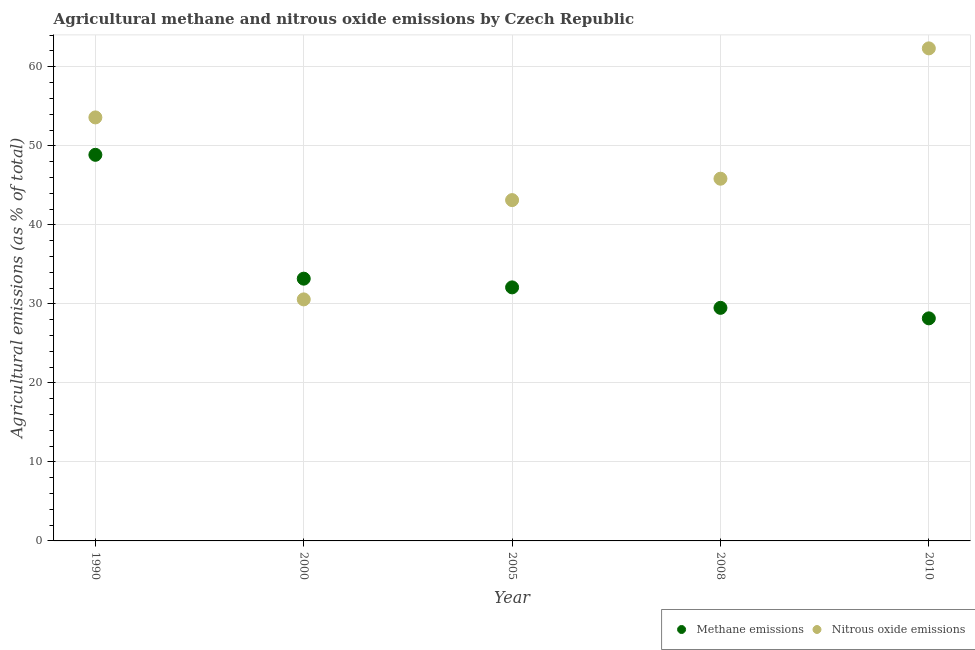What is the amount of methane emissions in 2000?
Your response must be concise. 33.19. Across all years, what is the maximum amount of nitrous oxide emissions?
Your answer should be very brief. 62.33. Across all years, what is the minimum amount of methane emissions?
Offer a very short reply. 28.17. In which year was the amount of nitrous oxide emissions minimum?
Offer a terse response. 2000. What is the total amount of nitrous oxide emissions in the graph?
Ensure brevity in your answer.  235.46. What is the difference between the amount of methane emissions in 1990 and that in 2005?
Keep it short and to the point. 16.78. What is the difference between the amount of nitrous oxide emissions in 2000 and the amount of methane emissions in 2008?
Your response must be concise. 1.07. What is the average amount of nitrous oxide emissions per year?
Your answer should be compact. 47.09. In the year 2000, what is the difference between the amount of methane emissions and amount of nitrous oxide emissions?
Your answer should be compact. 2.62. What is the ratio of the amount of methane emissions in 1990 to that in 2010?
Keep it short and to the point. 1.73. What is the difference between the highest and the second highest amount of methane emissions?
Your response must be concise. 15.67. What is the difference between the highest and the lowest amount of nitrous oxide emissions?
Your response must be concise. 31.77. In how many years, is the amount of methane emissions greater than the average amount of methane emissions taken over all years?
Keep it short and to the point. 1. Is the sum of the amount of methane emissions in 2000 and 2010 greater than the maximum amount of nitrous oxide emissions across all years?
Give a very brief answer. No. How many years are there in the graph?
Make the answer very short. 5. What is the difference between two consecutive major ticks on the Y-axis?
Your response must be concise. 10. Are the values on the major ticks of Y-axis written in scientific E-notation?
Your answer should be compact. No. Does the graph contain any zero values?
Give a very brief answer. No. Does the graph contain grids?
Your response must be concise. Yes. Where does the legend appear in the graph?
Provide a succinct answer. Bottom right. What is the title of the graph?
Provide a succinct answer. Agricultural methane and nitrous oxide emissions by Czech Republic. What is the label or title of the X-axis?
Offer a terse response. Year. What is the label or title of the Y-axis?
Give a very brief answer. Agricultural emissions (as % of total). What is the Agricultural emissions (as % of total) in Methane emissions in 1990?
Offer a very short reply. 48.86. What is the Agricultural emissions (as % of total) in Nitrous oxide emissions in 1990?
Your answer should be very brief. 53.6. What is the Agricultural emissions (as % of total) of Methane emissions in 2000?
Your answer should be very brief. 33.19. What is the Agricultural emissions (as % of total) of Nitrous oxide emissions in 2000?
Offer a terse response. 30.56. What is the Agricultural emissions (as % of total) in Methane emissions in 2005?
Your response must be concise. 32.09. What is the Agricultural emissions (as % of total) in Nitrous oxide emissions in 2005?
Offer a very short reply. 43.13. What is the Agricultural emissions (as % of total) of Methane emissions in 2008?
Offer a very short reply. 29.49. What is the Agricultural emissions (as % of total) of Nitrous oxide emissions in 2008?
Offer a very short reply. 45.84. What is the Agricultural emissions (as % of total) in Methane emissions in 2010?
Ensure brevity in your answer.  28.17. What is the Agricultural emissions (as % of total) in Nitrous oxide emissions in 2010?
Provide a short and direct response. 62.33. Across all years, what is the maximum Agricultural emissions (as % of total) of Methane emissions?
Give a very brief answer. 48.86. Across all years, what is the maximum Agricultural emissions (as % of total) of Nitrous oxide emissions?
Keep it short and to the point. 62.33. Across all years, what is the minimum Agricultural emissions (as % of total) in Methane emissions?
Provide a succinct answer. 28.17. Across all years, what is the minimum Agricultural emissions (as % of total) in Nitrous oxide emissions?
Offer a terse response. 30.56. What is the total Agricultural emissions (as % of total) of Methane emissions in the graph?
Your response must be concise. 171.8. What is the total Agricultural emissions (as % of total) in Nitrous oxide emissions in the graph?
Offer a terse response. 235.46. What is the difference between the Agricultural emissions (as % of total) in Methane emissions in 1990 and that in 2000?
Offer a terse response. 15.67. What is the difference between the Agricultural emissions (as % of total) of Nitrous oxide emissions in 1990 and that in 2000?
Keep it short and to the point. 23.03. What is the difference between the Agricultural emissions (as % of total) in Methane emissions in 1990 and that in 2005?
Make the answer very short. 16.78. What is the difference between the Agricultural emissions (as % of total) in Nitrous oxide emissions in 1990 and that in 2005?
Offer a very short reply. 10.47. What is the difference between the Agricultural emissions (as % of total) of Methane emissions in 1990 and that in 2008?
Your answer should be very brief. 19.37. What is the difference between the Agricultural emissions (as % of total) in Nitrous oxide emissions in 1990 and that in 2008?
Ensure brevity in your answer.  7.76. What is the difference between the Agricultural emissions (as % of total) of Methane emissions in 1990 and that in 2010?
Make the answer very short. 20.7. What is the difference between the Agricultural emissions (as % of total) in Nitrous oxide emissions in 1990 and that in 2010?
Your response must be concise. -8.74. What is the difference between the Agricultural emissions (as % of total) in Methane emissions in 2000 and that in 2005?
Give a very brief answer. 1.1. What is the difference between the Agricultural emissions (as % of total) of Nitrous oxide emissions in 2000 and that in 2005?
Your response must be concise. -12.57. What is the difference between the Agricultural emissions (as % of total) in Methane emissions in 2000 and that in 2008?
Offer a very short reply. 3.69. What is the difference between the Agricultural emissions (as % of total) in Nitrous oxide emissions in 2000 and that in 2008?
Your answer should be compact. -15.27. What is the difference between the Agricultural emissions (as % of total) in Methane emissions in 2000 and that in 2010?
Ensure brevity in your answer.  5.02. What is the difference between the Agricultural emissions (as % of total) in Nitrous oxide emissions in 2000 and that in 2010?
Give a very brief answer. -31.77. What is the difference between the Agricultural emissions (as % of total) of Methane emissions in 2005 and that in 2008?
Provide a short and direct response. 2.59. What is the difference between the Agricultural emissions (as % of total) of Nitrous oxide emissions in 2005 and that in 2008?
Your response must be concise. -2.71. What is the difference between the Agricultural emissions (as % of total) of Methane emissions in 2005 and that in 2010?
Keep it short and to the point. 3.92. What is the difference between the Agricultural emissions (as % of total) of Nitrous oxide emissions in 2005 and that in 2010?
Offer a terse response. -19.2. What is the difference between the Agricultural emissions (as % of total) in Methane emissions in 2008 and that in 2010?
Make the answer very short. 1.33. What is the difference between the Agricultural emissions (as % of total) in Nitrous oxide emissions in 2008 and that in 2010?
Provide a succinct answer. -16.49. What is the difference between the Agricultural emissions (as % of total) in Methane emissions in 1990 and the Agricultural emissions (as % of total) in Nitrous oxide emissions in 2000?
Make the answer very short. 18.3. What is the difference between the Agricultural emissions (as % of total) of Methane emissions in 1990 and the Agricultural emissions (as % of total) of Nitrous oxide emissions in 2005?
Offer a terse response. 5.73. What is the difference between the Agricultural emissions (as % of total) in Methane emissions in 1990 and the Agricultural emissions (as % of total) in Nitrous oxide emissions in 2008?
Provide a short and direct response. 3.02. What is the difference between the Agricultural emissions (as % of total) in Methane emissions in 1990 and the Agricultural emissions (as % of total) in Nitrous oxide emissions in 2010?
Your answer should be compact. -13.47. What is the difference between the Agricultural emissions (as % of total) in Methane emissions in 2000 and the Agricultural emissions (as % of total) in Nitrous oxide emissions in 2005?
Provide a succinct answer. -9.94. What is the difference between the Agricultural emissions (as % of total) of Methane emissions in 2000 and the Agricultural emissions (as % of total) of Nitrous oxide emissions in 2008?
Offer a terse response. -12.65. What is the difference between the Agricultural emissions (as % of total) in Methane emissions in 2000 and the Agricultural emissions (as % of total) in Nitrous oxide emissions in 2010?
Offer a terse response. -29.14. What is the difference between the Agricultural emissions (as % of total) in Methane emissions in 2005 and the Agricultural emissions (as % of total) in Nitrous oxide emissions in 2008?
Your response must be concise. -13.75. What is the difference between the Agricultural emissions (as % of total) in Methane emissions in 2005 and the Agricultural emissions (as % of total) in Nitrous oxide emissions in 2010?
Give a very brief answer. -30.25. What is the difference between the Agricultural emissions (as % of total) of Methane emissions in 2008 and the Agricultural emissions (as % of total) of Nitrous oxide emissions in 2010?
Your answer should be very brief. -32.84. What is the average Agricultural emissions (as % of total) in Methane emissions per year?
Provide a succinct answer. 34.36. What is the average Agricultural emissions (as % of total) of Nitrous oxide emissions per year?
Keep it short and to the point. 47.09. In the year 1990, what is the difference between the Agricultural emissions (as % of total) of Methane emissions and Agricultural emissions (as % of total) of Nitrous oxide emissions?
Make the answer very short. -4.73. In the year 2000, what is the difference between the Agricultural emissions (as % of total) of Methane emissions and Agricultural emissions (as % of total) of Nitrous oxide emissions?
Provide a short and direct response. 2.62. In the year 2005, what is the difference between the Agricultural emissions (as % of total) in Methane emissions and Agricultural emissions (as % of total) in Nitrous oxide emissions?
Ensure brevity in your answer.  -11.04. In the year 2008, what is the difference between the Agricultural emissions (as % of total) of Methane emissions and Agricultural emissions (as % of total) of Nitrous oxide emissions?
Ensure brevity in your answer.  -16.34. In the year 2010, what is the difference between the Agricultural emissions (as % of total) of Methane emissions and Agricultural emissions (as % of total) of Nitrous oxide emissions?
Your response must be concise. -34.17. What is the ratio of the Agricultural emissions (as % of total) of Methane emissions in 1990 to that in 2000?
Provide a succinct answer. 1.47. What is the ratio of the Agricultural emissions (as % of total) of Nitrous oxide emissions in 1990 to that in 2000?
Provide a succinct answer. 1.75. What is the ratio of the Agricultural emissions (as % of total) of Methane emissions in 1990 to that in 2005?
Your answer should be very brief. 1.52. What is the ratio of the Agricultural emissions (as % of total) of Nitrous oxide emissions in 1990 to that in 2005?
Offer a very short reply. 1.24. What is the ratio of the Agricultural emissions (as % of total) of Methane emissions in 1990 to that in 2008?
Provide a succinct answer. 1.66. What is the ratio of the Agricultural emissions (as % of total) in Nitrous oxide emissions in 1990 to that in 2008?
Provide a succinct answer. 1.17. What is the ratio of the Agricultural emissions (as % of total) of Methane emissions in 1990 to that in 2010?
Ensure brevity in your answer.  1.73. What is the ratio of the Agricultural emissions (as % of total) of Nitrous oxide emissions in 1990 to that in 2010?
Provide a succinct answer. 0.86. What is the ratio of the Agricultural emissions (as % of total) of Methane emissions in 2000 to that in 2005?
Your answer should be compact. 1.03. What is the ratio of the Agricultural emissions (as % of total) of Nitrous oxide emissions in 2000 to that in 2005?
Your response must be concise. 0.71. What is the ratio of the Agricultural emissions (as % of total) of Methane emissions in 2000 to that in 2008?
Your answer should be compact. 1.13. What is the ratio of the Agricultural emissions (as % of total) in Nitrous oxide emissions in 2000 to that in 2008?
Offer a terse response. 0.67. What is the ratio of the Agricultural emissions (as % of total) of Methane emissions in 2000 to that in 2010?
Your answer should be compact. 1.18. What is the ratio of the Agricultural emissions (as % of total) in Nitrous oxide emissions in 2000 to that in 2010?
Your response must be concise. 0.49. What is the ratio of the Agricultural emissions (as % of total) in Methane emissions in 2005 to that in 2008?
Provide a short and direct response. 1.09. What is the ratio of the Agricultural emissions (as % of total) of Nitrous oxide emissions in 2005 to that in 2008?
Your answer should be compact. 0.94. What is the ratio of the Agricultural emissions (as % of total) of Methane emissions in 2005 to that in 2010?
Keep it short and to the point. 1.14. What is the ratio of the Agricultural emissions (as % of total) of Nitrous oxide emissions in 2005 to that in 2010?
Provide a short and direct response. 0.69. What is the ratio of the Agricultural emissions (as % of total) of Methane emissions in 2008 to that in 2010?
Your answer should be compact. 1.05. What is the ratio of the Agricultural emissions (as % of total) of Nitrous oxide emissions in 2008 to that in 2010?
Provide a succinct answer. 0.74. What is the difference between the highest and the second highest Agricultural emissions (as % of total) of Methane emissions?
Offer a very short reply. 15.67. What is the difference between the highest and the second highest Agricultural emissions (as % of total) of Nitrous oxide emissions?
Provide a succinct answer. 8.74. What is the difference between the highest and the lowest Agricultural emissions (as % of total) of Methane emissions?
Make the answer very short. 20.7. What is the difference between the highest and the lowest Agricultural emissions (as % of total) in Nitrous oxide emissions?
Give a very brief answer. 31.77. 